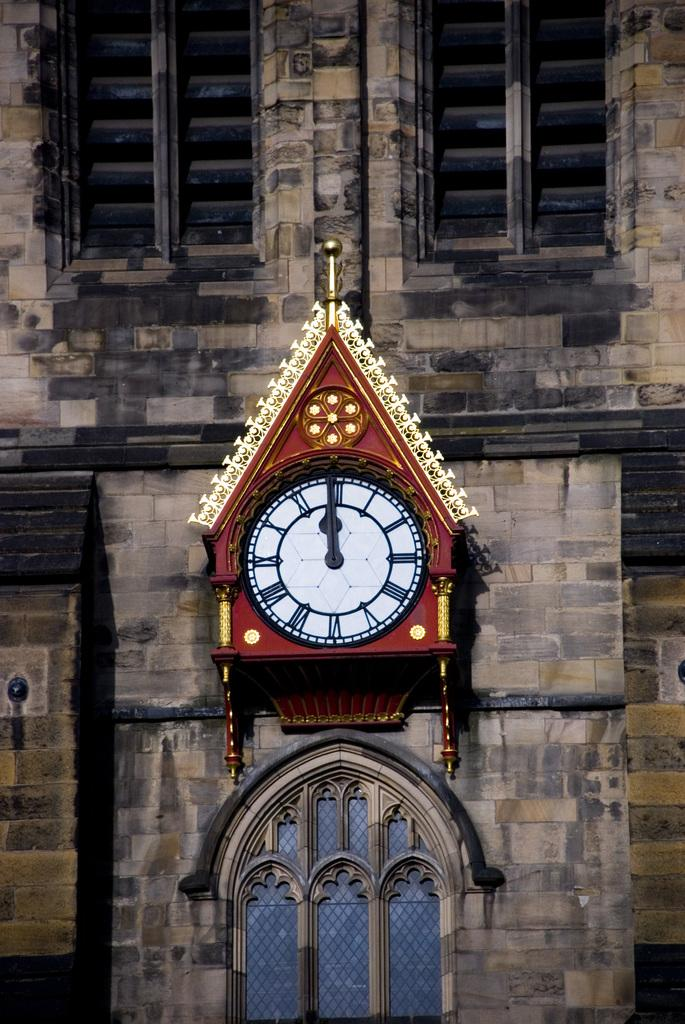Provide a one-sentence caption for the provided image. a clock with roman numerals at midnight. 